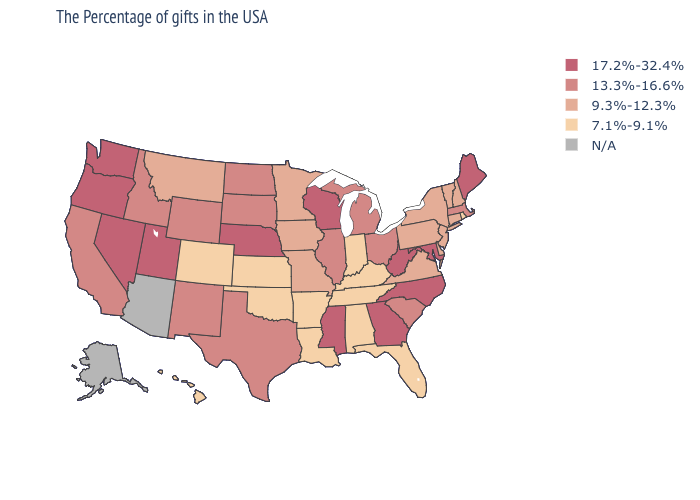Is the legend a continuous bar?
Be succinct. No. Does Oklahoma have the lowest value in the USA?
Answer briefly. Yes. What is the value of Tennessee?
Be succinct. 7.1%-9.1%. What is the highest value in the USA?
Concise answer only. 17.2%-32.4%. Among the states that border Montana , which have the highest value?
Answer briefly. South Dakota, North Dakota, Wyoming, Idaho. How many symbols are there in the legend?
Keep it brief. 5. Among the states that border Washington , does Idaho have the lowest value?
Keep it brief. Yes. What is the value of West Virginia?
Give a very brief answer. 17.2%-32.4%. What is the value of Connecticut?
Answer briefly. 9.3%-12.3%. What is the value of New Mexico?
Keep it brief. 13.3%-16.6%. What is the value of South Dakota?
Keep it brief. 13.3%-16.6%. Name the states that have a value in the range 7.1%-9.1%?
Give a very brief answer. Rhode Island, Florida, Kentucky, Indiana, Alabama, Tennessee, Louisiana, Arkansas, Kansas, Oklahoma, Colorado, Hawaii. Among the states that border Maine , which have the highest value?
Write a very short answer. New Hampshire. Name the states that have a value in the range 17.2%-32.4%?
Keep it brief. Maine, Maryland, North Carolina, West Virginia, Georgia, Wisconsin, Mississippi, Nebraska, Utah, Nevada, Washington, Oregon. How many symbols are there in the legend?
Quick response, please. 5. 